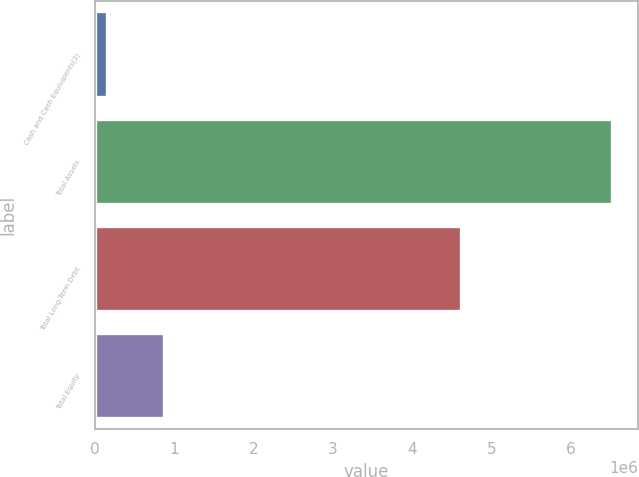<chart> <loc_0><loc_0><loc_500><loc_500><bar_chart><fcel>Cash and Cash Equivalents(3)<fcel>Total Assets<fcel>Total Long-Term Debt<fcel>Total Equity<nl><fcel>159793<fcel>6.52326e+06<fcel>4.61645e+06<fcel>869955<nl></chart> 